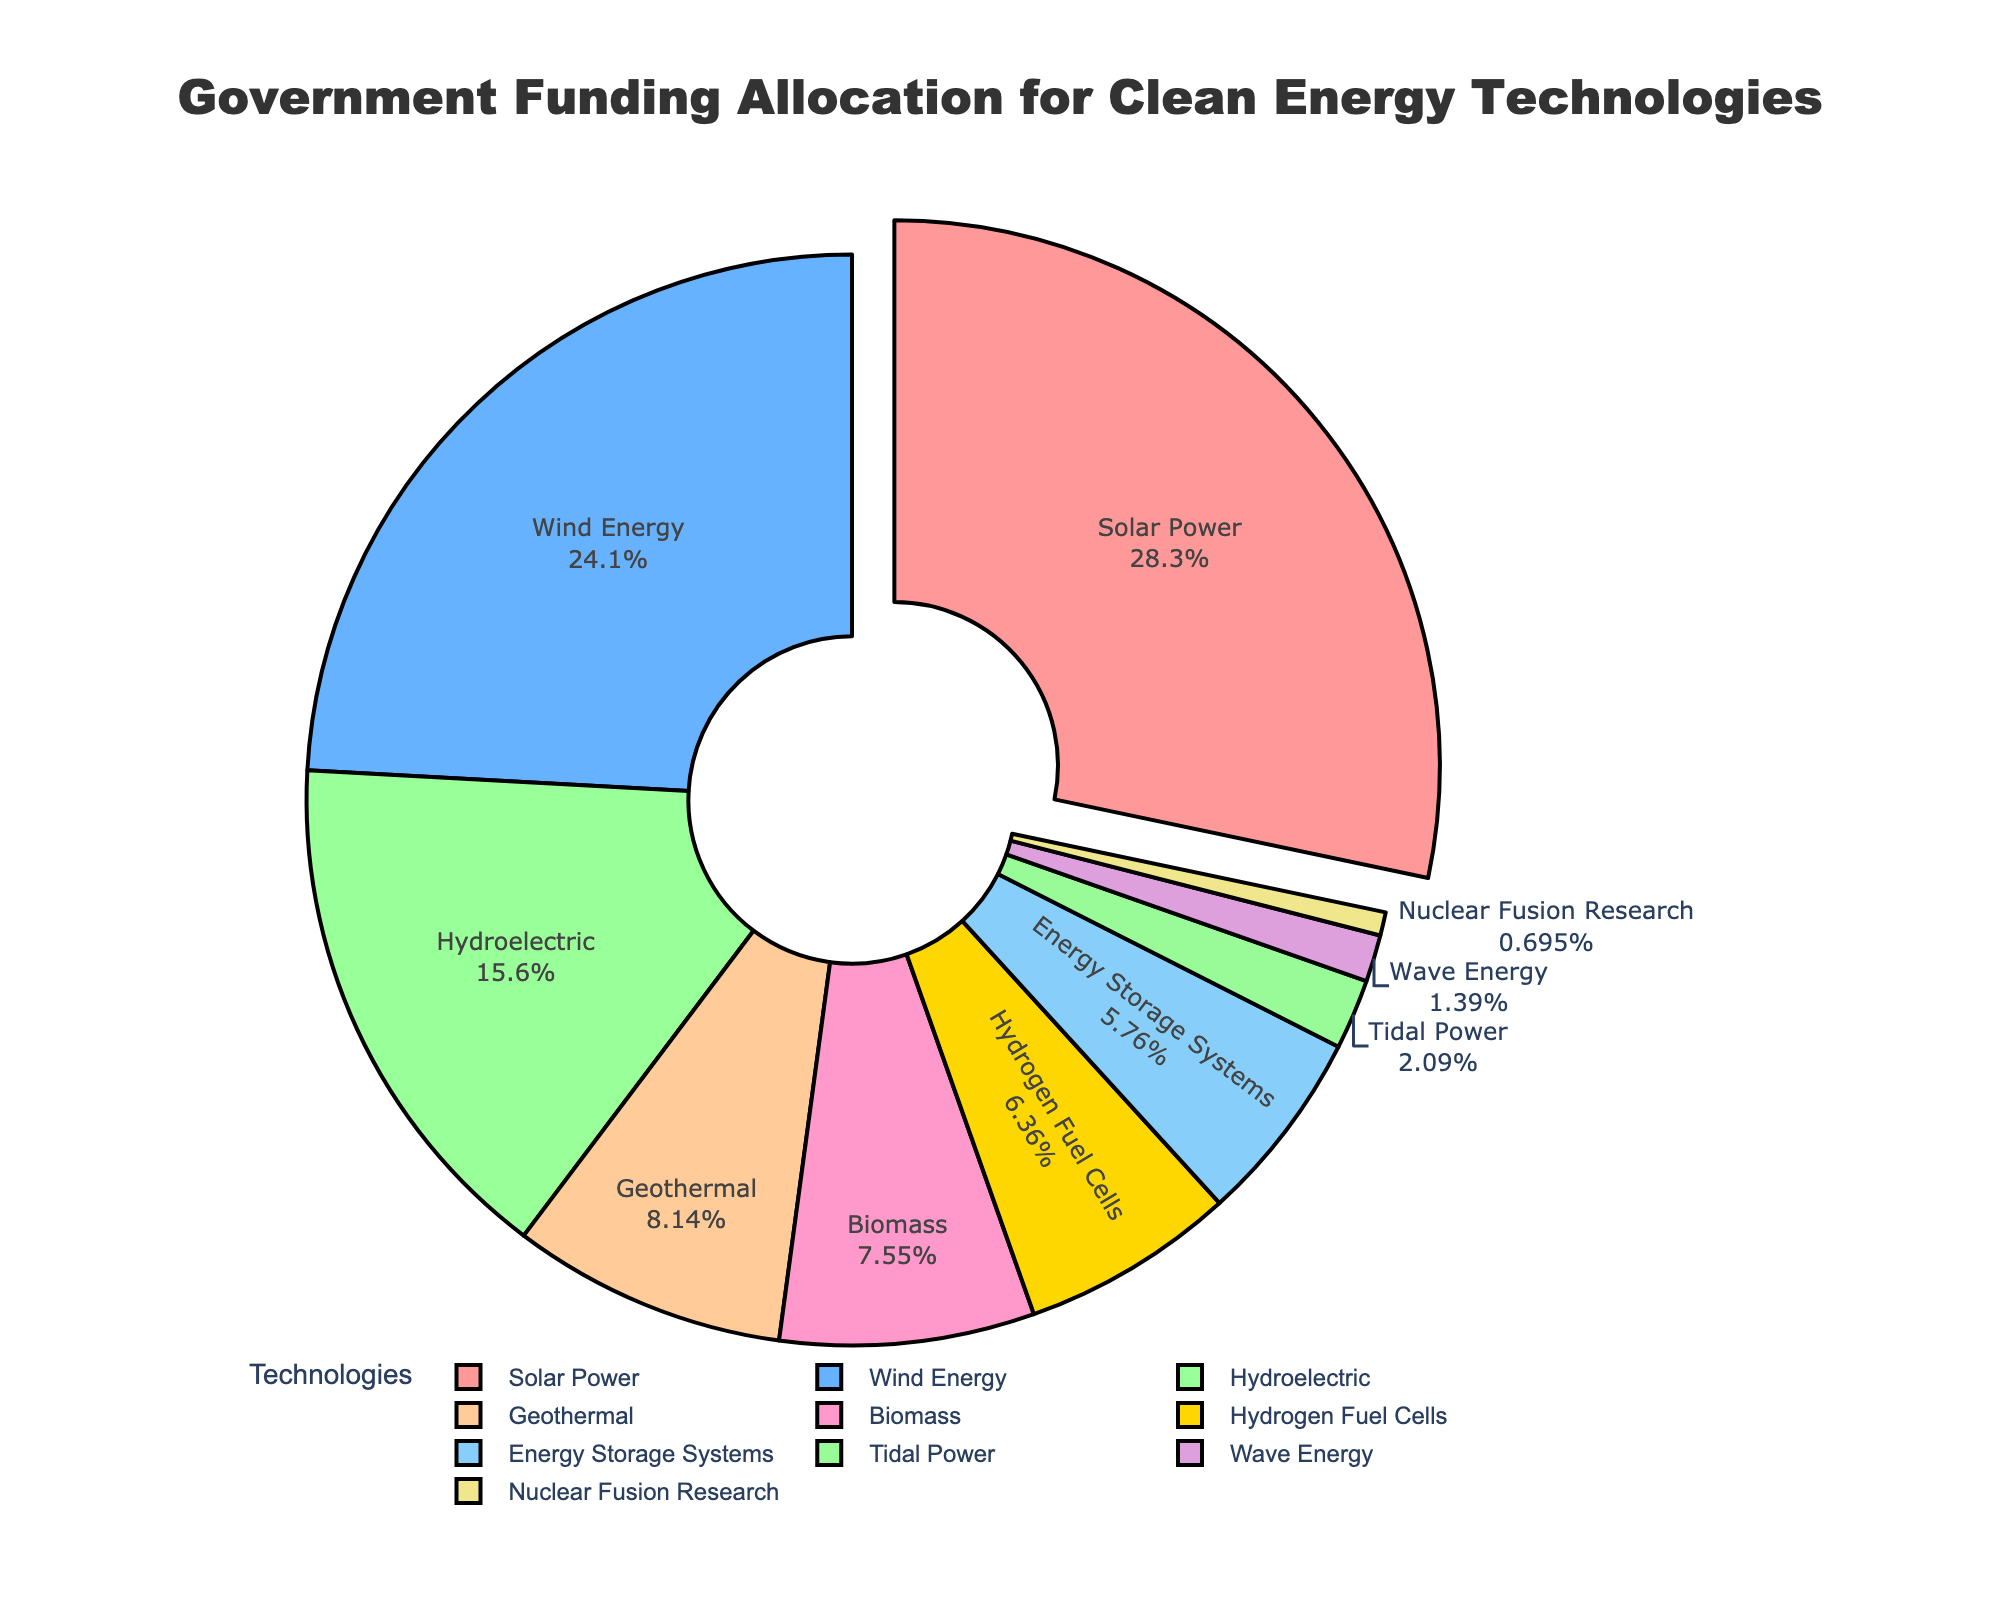what is the largest funding allocation and to which technology was it allocated? The chart shows that the largest percentage of government funding is allocated to Solar Power, marked as 28.5%. This is also visually represented by the slice that is slightly pulled out of the pie chart.
Answer: Solar Power, 28.5% Which three technologies have the smallest funding allocations? From the chart, the three smallest slices correspond to Nuclear Fusion Research, Wave Energy, and Tidal Power. Their respective funding percentages are 0.7%, 1.4%, and 2.1%.
Answer: Nuclear Fusion Research, Wave Energy, Tidal Power How much more funding does Solar Power receive compared to Wind Energy? According to the chart, Solar Power receives 28.5% of the funding while Wind Energy receives 24.3%. The difference between these allocations can be calculated as 28.5% - 24.3% = 4.2%.
Answer: 4.2% What is the combined funding allocation for Energy Storage Systems, Biomass, and Geothermal? Energy Storage Systems receive 5.8% of the funding, Biomass gets 7.6%, and Geothermal gets 8.2%. Adding these together: 5.8% + 7.6% + 8.2% = 21.6%.
Answer: 21.6% Which technology receives more funding, Hydroelectric or Hydrogen Fuel Cells, and by how much? The chart indicates Hydroelectric gets 15.7% while Hydrogen Fuel Cells receive 6.4%. The difference can be calculated as 15.7% - 6.4% = 9.3%.
Answer: Hydroelectric, 9.3% What percentage of the total funding is allocated to both Wind Energy and Biomass combined? Wind Energy receives 24.3% and Biomass receives 7.6%. Combined, this is 24.3% + 7.6% = 31.9%.
Answer: 31.9% Among the top three funded technologies, which one receives the second highest allocation? The top three funded technologies are Solar Power (28.5%), Wind Energy (24.3%), and Hydroelectric (15.7%). Among these, Wind Energy receives the second highest allocation of 24.3%.
Answer: Wind Energy, 24.3% What is the average funding allocation percentage for the technologies receiving more than 5% funding? Technologies receiving more than 5% funding are Solar Power (28.5%), Wind Energy (24.3%), Hydroelectric (15.7%), Geothermal (8.2%), Biomass (7.6%), and Energy Storage Systems (5.8%). Their average is calculated as (28.5 + 24.3 + 15.7 + 8.2 + 7.6 + 5.8) / 6 = 15.017%.
Answer: 15.017% 